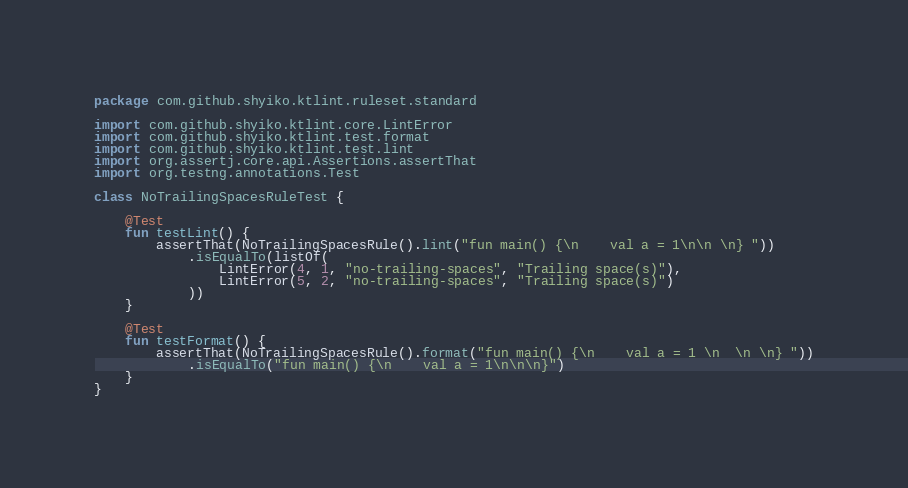<code> <loc_0><loc_0><loc_500><loc_500><_Kotlin_>package com.github.shyiko.ktlint.ruleset.standard

import com.github.shyiko.ktlint.core.LintError
import com.github.shyiko.ktlint.test.format
import com.github.shyiko.ktlint.test.lint
import org.assertj.core.api.Assertions.assertThat
import org.testng.annotations.Test

class NoTrailingSpacesRuleTest {

    @Test
    fun testLint() {
        assertThat(NoTrailingSpacesRule().lint("fun main() {\n    val a = 1\n\n \n} "))
            .isEqualTo(listOf(
                LintError(4, 1, "no-trailing-spaces", "Trailing space(s)"),
                LintError(5, 2, "no-trailing-spaces", "Trailing space(s)")
            ))
    }

    @Test
    fun testFormat() {
        assertThat(NoTrailingSpacesRule().format("fun main() {\n    val a = 1 \n  \n \n} "))
            .isEqualTo("fun main() {\n    val a = 1\n\n\n}")
    }
}
</code> 